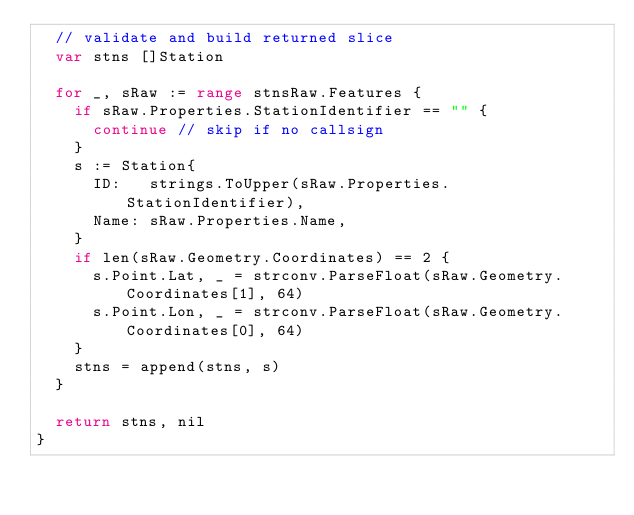Convert code to text. <code><loc_0><loc_0><loc_500><loc_500><_Go_>	// validate and build returned slice
	var stns []Station

	for _, sRaw := range stnsRaw.Features {
		if sRaw.Properties.StationIdentifier == "" {
			continue // skip if no callsign
		}
		s := Station{
			ID:   strings.ToUpper(sRaw.Properties.StationIdentifier),
			Name: sRaw.Properties.Name,
		}
		if len(sRaw.Geometry.Coordinates) == 2 {
			s.Point.Lat, _ = strconv.ParseFloat(sRaw.Geometry.Coordinates[1], 64)
			s.Point.Lon, _ = strconv.ParseFloat(sRaw.Geometry.Coordinates[0], 64)
		}
		stns = append(stns, s)
	}

	return stns, nil
}
</code> 